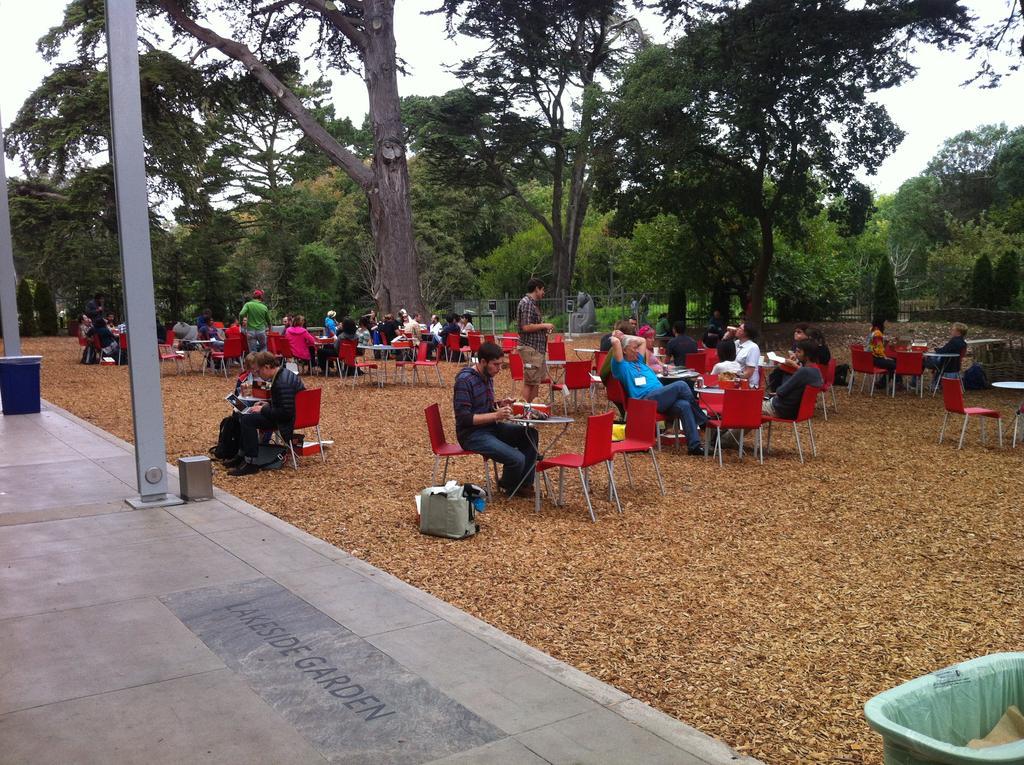Could you give a brief overview of what you see in this image? In the image we can see group of persons were sitting on the chair around the table. On table,we can see some food item,on the right there is a dustbin. In the background we can see sky,trees,fence,plant and dry leaves. 